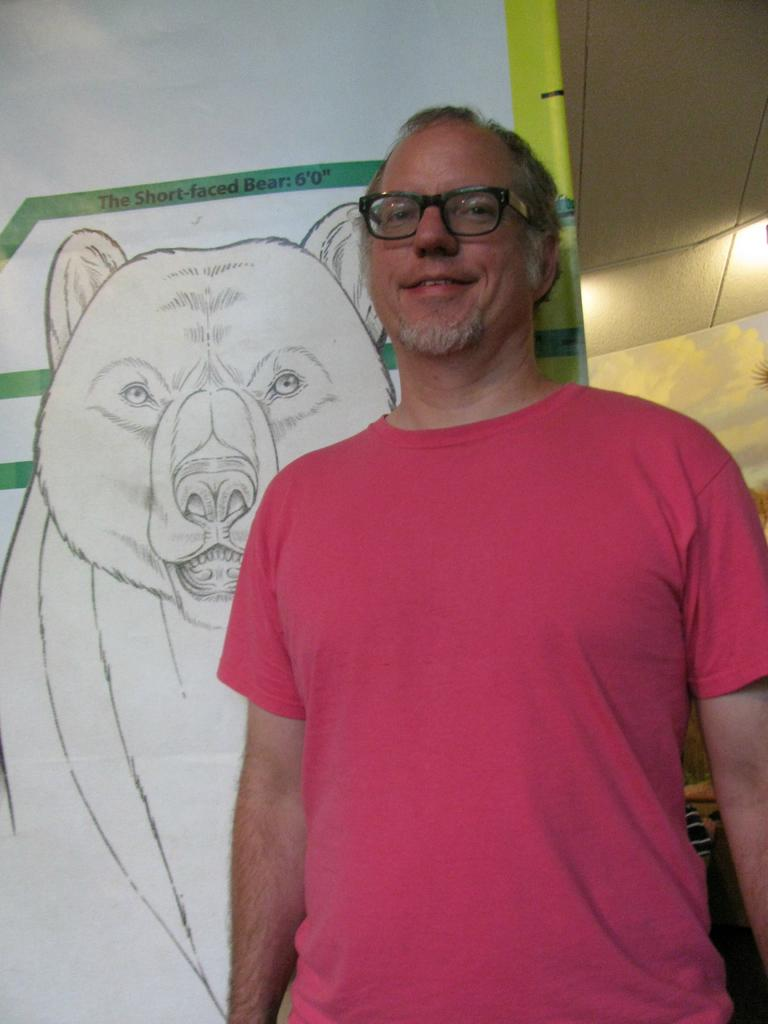Who is present in the image? There is a man in the image. What is the man wearing? The man is wearing a t-shirt. What can be seen on the wall on the left side of the image? There is a diagram of a bear on the wall on the left side of the image. What type of operation is being performed on the man's chin in the image? There is no operation or any reference to a chin in the image; it only features a man wearing a t-shirt and a bear diagram on the wall. 